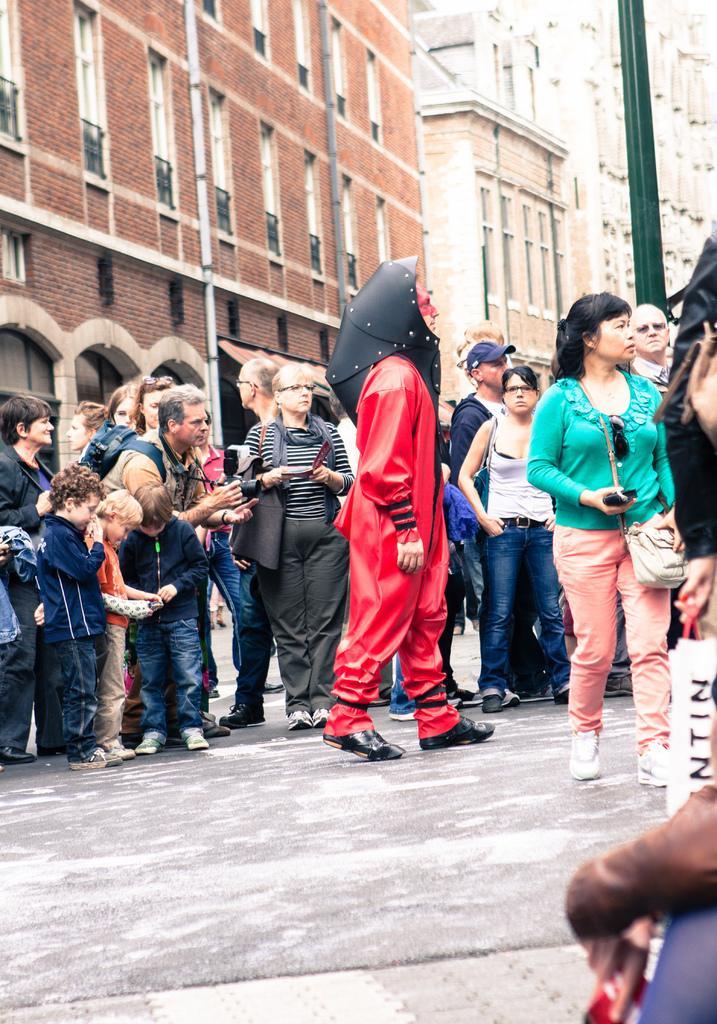Describe this image in one or two sentences. In this image there is a person in a fancy dress is standing on the road, and there are group of people standing ,and in the background there are buildings. 